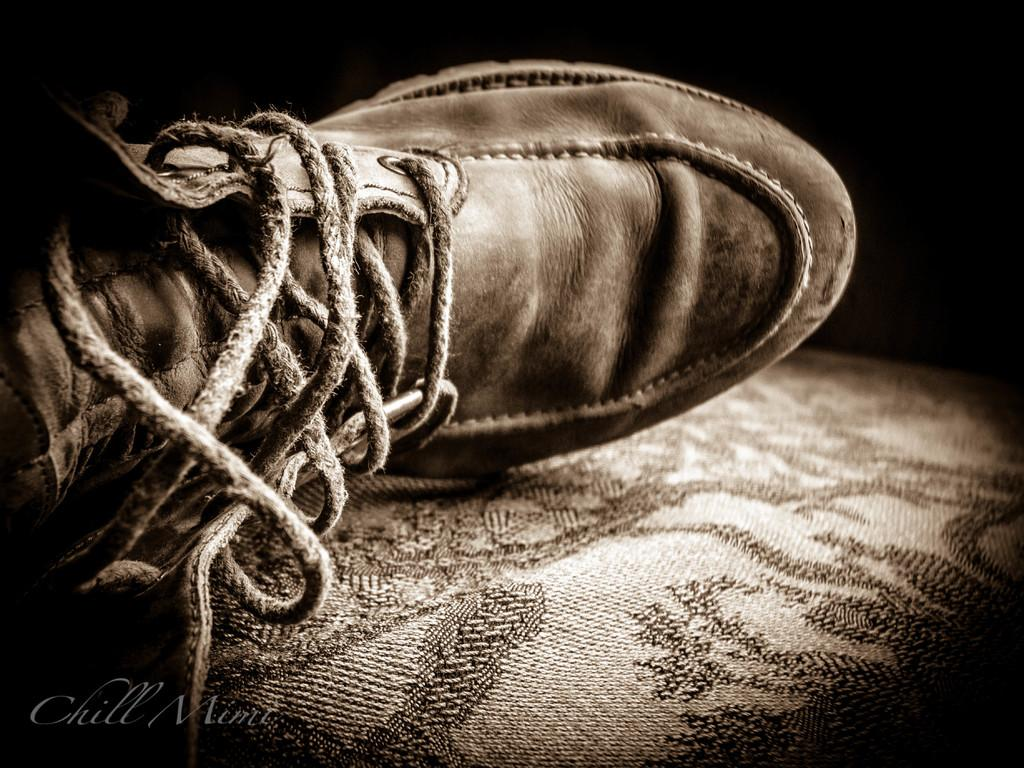What object is in the image? There is a shoe in the image. Where is the shoe located? The shoe is on a couch. What type of property is being sold in the image? There is no property being sold in the image; it only features a shoe on a couch. 